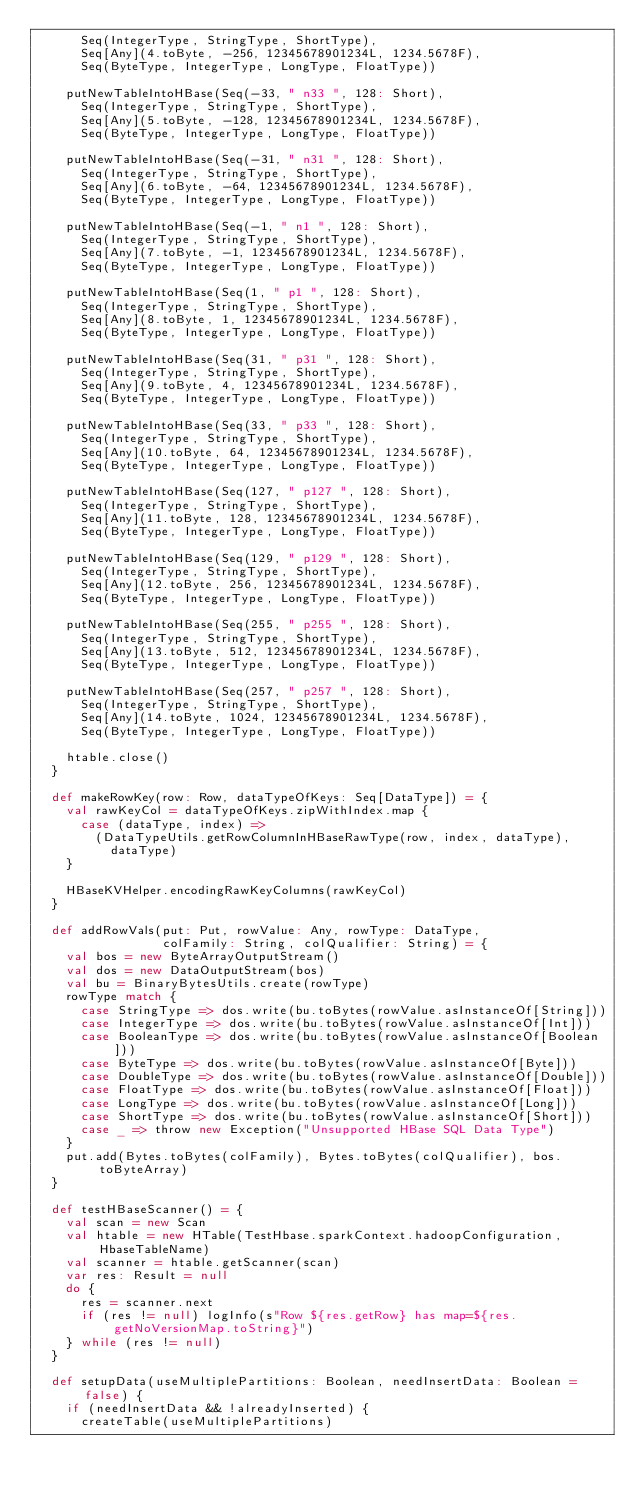<code> <loc_0><loc_0><loc_500><loc_500><_Scala_>      Seq(IntegerType, StringType, ShortType),
      Seq[Any](4.toByte, -256, 12345678901234L, 1234.5678F),
      Seq(ByteType, IntegerType, LongType, FloatType))

    putNewTableIntoHBase(Seq(-33, " n33 ", 128: Short),
      Seq(IntegerType, StringType, ShortType),
      Seq[Any](5.toByte, -128, 12345678901234L, 1234.5678F),
      Seq(ByteType, IntegerType, LongType, FloatType))

    putNewTableIntoHBase(Seq(-31, " n31 ", 128: Short),
      Seq(IntegerType, StringType, ShortType),
      Seq[Any](6.toByte, -64, 12345678901234L, 1234.5678F),
      Seq(ByteType, IntegerType, LongType, FloatType))

    putNewTableIntoHBase(Seq(-1, " n1 ", 128: Short),
      Seq(IntegerType, StringType, ShortType),
      Seq[Any](7.toByte, -1, 12345678901234L, 1234.5678F),
      Seq(ByteType, IntegerType, LongType, FloatType))

    putNewTableIntoHBase(Seq(1, " p1 ", 128: Short),
      Seq(IntegerType, StringType, ShortType),
      Seq[Any](8.toByte, 1, 12345678901234L, 1234.5678F),
      Seq(ByteType, IntegerType, LongType, FloatType))

    putNewTableIntoHBase(Seq(31, " p31 ", 128: Short),
      Seq(IntegerType, StringType, ShortType),
      Seq[Any](9.toByte, 4, 12345678901234L, 1234.5678F),
      Seq(ByteType, IntegerType, LongType, FloatType))

    putNewTableIntoHBase(Seq(33, " p33 ", 128: Short),
      Seq(IntegerType, StringType, ShortType),
      Seq[Any](10.toByte, 64, 12345678901234L, 1234.5678F),
      Seq(ByteType, IntegerType, LongType, FloatType))

    putNewTableIntoHBase(Seq(127, " p127 ", 128: Short),
      Seq(IntegerType, StringType, ShortType),
      Seq[Any](11.toByte, 128, 12345678901234L, 1234.5678F),
      Seq(ByteType, IntegerType, LongType, FloatType))

    putNewTableIntoHBase(Seq(129, " p129 ", 128: Short),
      Seq(IntegerType, StringType, ShortType),
      Seq[Any](12.toByte, 256, 12345678901234L, 1234.5678F),
      Seq(ByteType, IntegerType, LongType, FloatType))

    putNewTableIntoHBase(Seq(255, " p255 ", 128: Short),
      Seq(IntegerType, StringType, ShortType),
      Seq[Any](13.toByte, 512, 12345678901234L, 1234.5678F),
      Seq(ByteType, IntegerType, LongType, FloatType))

    putNewTableIntoHBase(Seq(257, " p257 ", 128: Short),
      Seq(IntegerType, StringType, ShortType),
      Seq[Any](14.toByte, 1024, 12345678901234L, 1234.5678F),
      Seq(ByteType, IntegerType, LongType, FloatType))

    htable.close()
  }

  def makeRowKey(row: Row, dataTypeOfKeys: Seq[DataType]) = {
    val rawKeyCol = dataTypeOfKeys.zipWithIndex.map {
      case (dataType, index) =>
        (DataTypeUtils.getRowColumnInHBaseRawType(row, index, dataType),
          dataType)
    }

    HBaseKVHelper.encodingRawKeyColumns(rawKeyCol)
  }

  def addRowVals(put: Put, rowValue: Any, rowType: DataType,
                 colFamily: String, colQualifier: String) = {
    val bos = new ByteArrayOutputStream()
    val dos = new DataOutputStream(bos)
    val bu = BinaryBytesUtils.create(rowType)
    rowType match {
      case StringType => dos.write(bu.toBytes(rowValue.asInstanceOf[String]))
      case IntegerType => dos.write(bu.toBytes(rowValue.asInstanceOf[Int]))
      case BooleanType => dos.write(bu.toBytes(rowValue.asInstanceOf[Boolean]))
      case ByteType => dos.write(bu.toBytes(rowValue.asInstanceOf[Byte]))
      case DoubleType => dos.write(bu.toBytes(rowValue.asInstanceOf[Double]))
      case FloatType => dos.write(bu.toBytes(rowValue.asInstanceOf[Float]))
      case LongType => dos.write(bu.toBytes(rowValue.asInstanceOf[Long]))
      case ShortType => dos.write(bu.toBytes(rowValue.asInstanceOf[Short]))
      case _ => throw new Exception("Unsupported HBase SQL Data Type")
    }
    put.add(Bytes.toBytes(colFamily), Bytes.toBytes(colQualifier), bos.toByteArray)
  }

  def testHBaseScanner() = {
    val scan = new Scan
    val htable = new HTable(TestHbase.sparkContext.hadoopConfiguration, HbaseTableName)
    val scanner = htable.getScanner(scan)
    var res: Result = null
    do {
      res = scanner.next
      if (res != null) logInfo(s"Row ${res.getRow} has map=${res.getNoVersionMap.toString}")
    } while (res != null)
  }

  def setupData(useMultiplePartitions: Boolean, needInsertData: Boolean = false) {
    if (needInsertData && !alreadyInserted) {
      createTable(useMultiplePartitions)</code> 